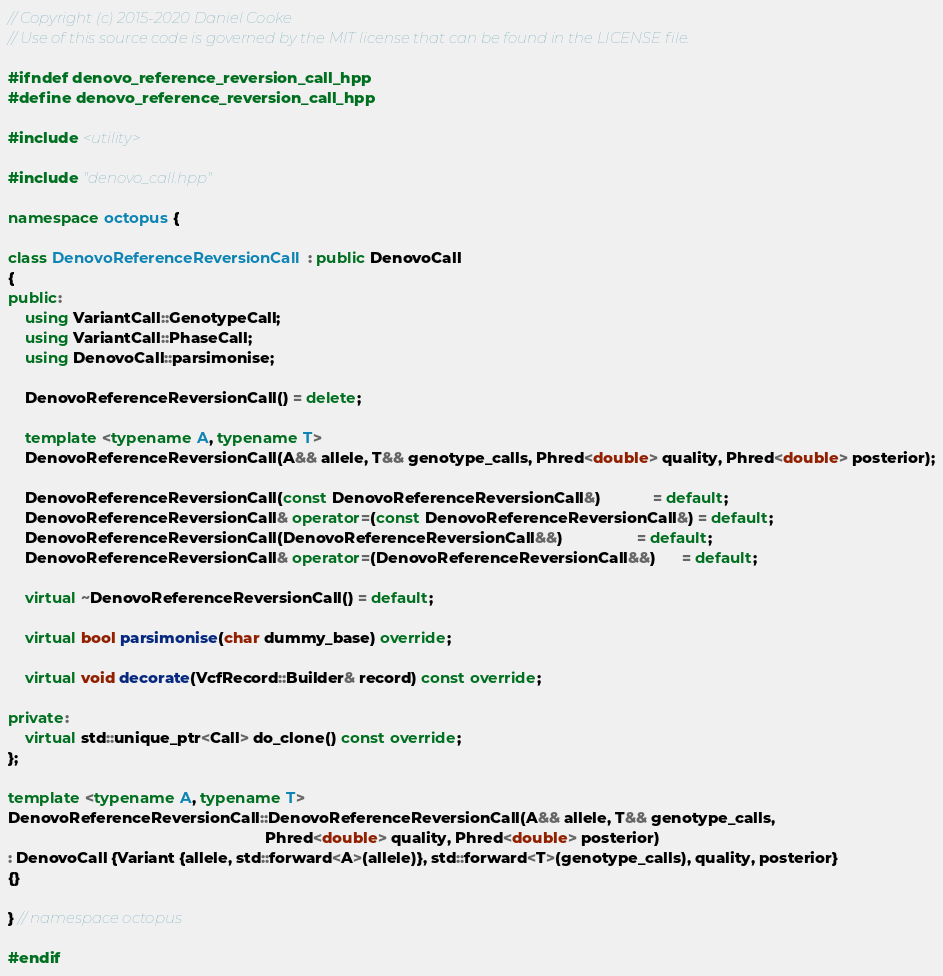Convert code to text. <code><loc_0><loc_0><loc_500><loc_500><_C++_>// Copyright (c) 2015-2020 Daniel Cooke
// Use of this source code is governed by the MIT license that can be found in the LICENSE file.

#ifndef denovo_reference_reversion_call_hpp
#define denovo_reference_reversion_call_hpp

#include <utility>

#include "denovo_call.hpp"

namespace octopus {

class DenovoReferenceReversionCall : public DenovoCall
{
public:
    using VariantCall::GenotypeCall;
    using VariantCall::PhaseCall;
    using DenovoCall::parsimonise;
    
    DenovoReferenceReversionCall() = delete;
    
    template <typename A, typename T>
    DenovoReferenceReversionCall(A&& allele, T&& genotype_calls, Phred<double> quality, Phred<double> posterior);
    
    DenovoReferenceReversionCall(const DenovoReferenceReversionCall&)            = default;
    DenovoReferenceReversionCall& operator=(const DenovoReferenceReversionCall&) = default;
    DenovoReferenceReversionCall(DenovoReferenceReversionCall&&)                 = default;
    DenovoReferenceReversionCall& operator=(DenovoReferenceReversionCall&&)      = default;
    
    virtual ~DenovoReferenceReversionCall() = default;
    
    virtual bool parsimonise(char dummy_base) override;
    
    virtual void decorate(VcfRecord::Builder& record) const override;
    
private:
    virtual std::unique_ptr<Call> do_clone() const override;
};

template <typename A, typename T>
DenovoReferenceReversionCall::DenovoReferenceReversionCall(A&& allele, T&& genotype_calls,
                                                           Phred<double> quality, Phred<double> posterior)
: DenovoCall {Variant {allele, std::forward<A>(allele)}, std::forward<T>(genotype_calls), quality, posterior}
{}

} // namespace octopus

#endif</code> 